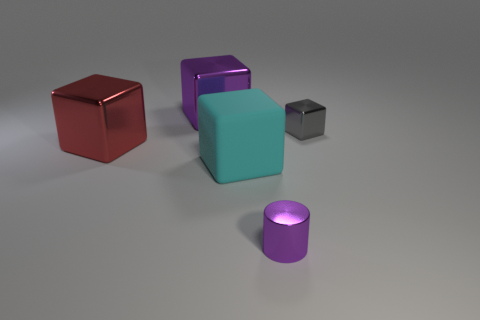Subtract all small blocks. How many blocks are left? 3 Subtract all red blocks. How many blocks are left? 3 Subtract all blocks. How many objects are left? 1 Add 1 large red metallic objects. How many objects exist? 6 Add 5 purple metal cubes. How many purple metal cubes exist? 6 Subtract 0 purple spheres. How many objects are left? 5 Subtract all blue cubes. Subtract all red cylinders. How many cubes are left? 4 Subtract all tiny gray shiny cubes. Subtract all large cubes. How many objects are left? 1 Add 4 small purple objects. How many small purple objects are left? 5 